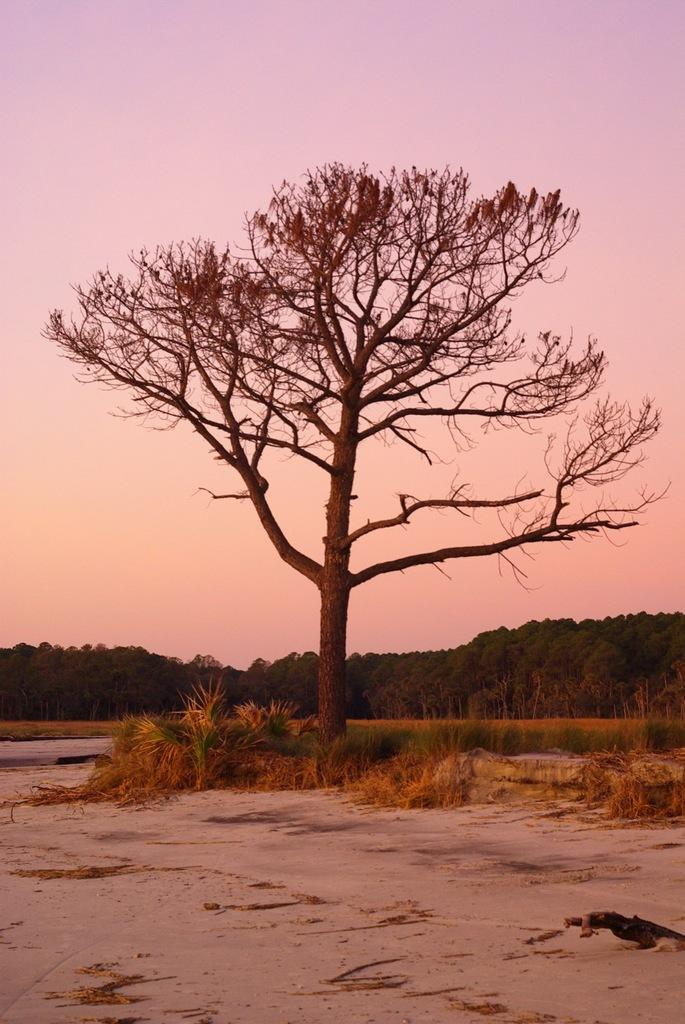What type of surface is visible in the image? There is a sandy surface in the image. What type of vegetation can be seen on the sandy surface? There are grass plants on the sandy surface. What other plant is visible in the image? There is a tree in the image. What can be seen in the background of the image? There are many trees visible in the background, and the sky is also visible. How many sheep are visible in the image? There are no sheep present in the image. What type of print can be seen on the tree trunks in the image? There is no print visible on the tree trunks in the image. 